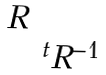Convert formula to latex. <formula><loc_0><loc_0><loc_500><loc_500>\begin{matrix} R & \\ & ^ { t } R ^ { - 1 } \end{matrix}</formula> 